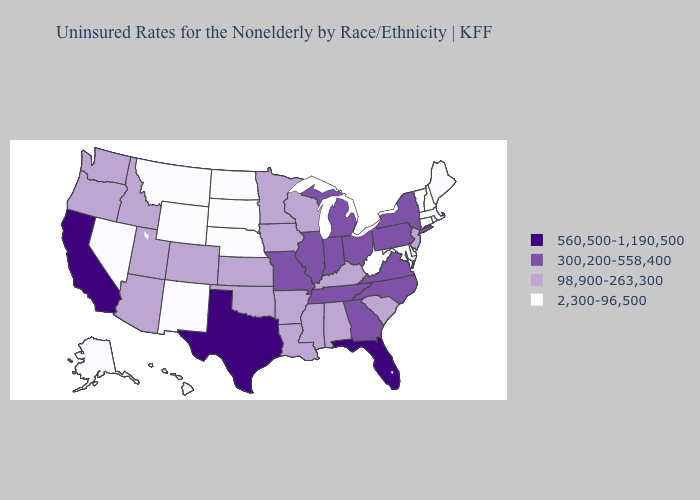What is the value of Tennessee?
Quick response, please. 300,200-558,400. Does Texas have the highest value in the South?
Short answer required. Yes. What is the value of Illinois?
Answer briefly. 300,200-558,400. Does South Dakota have the same value as Missouri?
Give a very brief answer. No. Does Kansas have a higher value than South Dakota?
Give a very brief answer. Yes. Name the states that have a value in the range 98,900-263,300?
Be succinct. Alabama, Arizona, Arkansas, Colorado, Idaho, Iowa, Kansas, Kentucky, Louisiana, Minnesota, Mississippi, New Jersey, Oklahoma, Oregon, South Carolina, Utah, Washington, Wisconsin. Name the states that have a value in the range 2,300-96,500?
Give a very brief answer. Alaska, Connecticut, Delaware, Hawaii, Maine, Maryland, Massachusetts, Montana, Nebraska, Nevada, New Hampshire, New Mexico, North Dakota, Rhode Island, South Dakota, Vermont, West Virginia, Wyoming. Does Arizona have the lowest value in the West?
Answer briefly. No. What is the lowest value in the USA?
Write a very short answer. 2,300-96,500. Does the map have missing data?
Short answer required. No. What is the value of Indiana?
Short answer required. 300,200-558,400. What is the value of Alaska?
Answer briefly. 2,300-96,500. What is the lowest value in states that border Texas?
Give a very brief answer. 2,300-96,500. What is the lowest value in states that border Missouri?
Keep it brief. 2,300-96,500. 